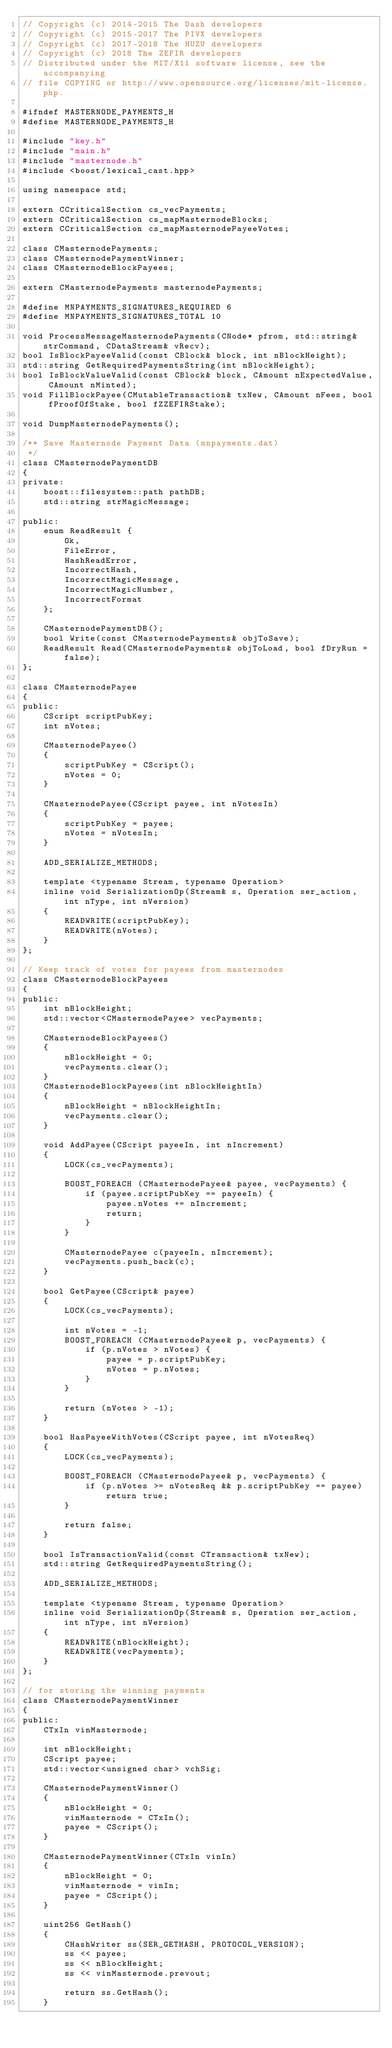<code> <loc_0><loc_0><loc_500><loc_500><_C_>// Copyright (c) 2014-2015 The Dash developers
// Copyright (c) 2015-2017 The PIVX developers
// Copyright (c) 2017-2018 The HUZU developers
// Copyright (c) 2018 The ZEFIR developers
// Distributed under the MIT/X11 software license, see the accompanying
// file COPYING or http://www.opensource.org/licenses/mit-license.php.

#ifndef MASTERNODE_PAYMENTS_H
#define MASTERNODE_PAYMENTS_H

#include "key.h"
#include "main.h"
#include "masternode.h"
#include <boost/lexical_cast.hpp>

using namespace std;

extern CCriticalSection cs_vecPayments;
extern CCriticalSection cs_mapMasternodeBlocks;
extern CCriticalSection cs_mapMasternodePayeeVotes;

class CMasternodePayments;
class CMasternodePaymentWinner;
class CMasternodeBlockPayees;

extern CMasternodePayments masternodePayments;

#define MNPAYMENTS_SIGNATURES_REQUIRED 6
#define MNPAYMENTS_SIGNATURES_TOTAL 10

void ProcessMessageMasternodePayments(CNode* pfrom, std::string& strCommand, CDataStream& vRecv);
bool IsBlockPayeeValid(const CBlock& block, int nBlockHeight);
std::string GetRequiredPaymentsString(int nBlockHeight);
bool IsBlockValueValid(const CBlock& block, CAmount nExpectedValue, CAmount nMinted);
void FillBlockPayee(CMutableTransaction& txNew, CAmount nFees, bool fProofOfStake, bool fZZEFIRStake);

void DumpMasternodePayments();

/** Save Masternode Payment Data (mnpayments.dat)
 */
class CMasternodePaymentDB
{
private:
    boost::filesystem::path pathDB;
    std::string strMagicMessage;

public:
    enum ReadResult {
        Ok,
        FileError,
        HashReadError,
        IncorrectHash,
        IncorrectMagicMessage,
        IncorrectMagicNumber,
        IncorrectFormat
    };

    CMasternodePaymentDB();
    bool Write(const CMasternodePayments& objToSave);
    ReadResult Read(CMasternodePayments& objToLoad, bool fDryRun = false);
};

class CMasternodePayee
{
public:
    CScript scriptPubKey;
    int nVotes;

    CMasternodePayee()
    {
        scriptPubKey = CScript();
        nVotes = 0;
    }

    CMasternodePayee(CScript payee, int nVotesIn)
    {
        scriptPubKey = payee;
        nVotes = nVotesIn;
    }

    ADD_SERIALIZE_METHODS;

    template <typename Stream, typename Operation>
    inline void SerializationOp(Stream& s, Operation ser_action, int nType, int nVersion)
    {
        READWRITE(scriptPubKey);
        READWRITE(nVotes);
    }
};

// Keep track of votes for payees from masternodes
class CMasternodeBlockPayees
{
public:
    int nBlockHeight;
    std::vector<CMasternodePayee> vecPayments;

    CMasternodeBlockPayees()
    {
        nBlockHeight = 0;
        vecPayments.clear();
    }
    CMasternodeBlockPayees(int nBlockHeightIn)
    {
        nBlockHeight = nBlockHeightIn;
        vecPayments.clear();
    }

    void AddPayee(CScript payeeIn, int nIncrement)
    {
        LOCK(cs_vecPayments);

        BOOST_FOREACH (CMasternodePayee& payee, vecPayments) {
            if (payee.scriptPubKey == payeeIn) {
                payee.nVotes += nIncrement;
                return;
            }
        }

        CMasternodePayee c(payeeIn, nIncrement);
        vecPayments.push_back(c);
    }

    bool GetPayee(CScript& payee)
    {
        LOCK(cs_vecPayments);

        int nVotes = -1;
        BOOST_FOREACH (CMasternodePayee& p, vecPayments) {
            if (p.nVotes > nVotes) {
                payee = p.scriptPubKey;
                nVotes = p.nVotes;
            }
        }

        return (nVotes > -1);
    }

    bool HasPayeeWithVotes(CScript payee, int nVotesReq)
    {
        LOCK(cs_vecPayments);

        BOOST_FOREACH (CMasternodePayee& p, vecPayments) {
            if (p.nVotes >= nVotesReq && p.scriptPubKey == payee) return true;
        }

        return false;
    }

    bool IsTransactionValid(const CTransaction& txNew);
    std::string GetRequiredPaymentsString();

    ADD_SERIALIZE_METHODS;

    template <typename Stream, typename Operation>
    inline void SerializationOp(Stream& s, Operation ser_action, int nType, int nVersion)
    {
        READWRITE(nBlockHeight);
        READWRITE(vecPayments);
    }
};

// for storing the winning payments
class CMasternodePaymentWinner
{
public:
    CTxIn vinMasternode;

    int nBlockHeight;
    CScript payee;
    std::vector<unsigned char> vchSig;

    CMasternodePaymentWinner()
    {
        nBlockHeight = 0;
        vinMasternode = CTxIn();
        payee = CScript();
    }

    CMasternodePaymentWinner(CTxIn vinIn)
    {
        nBlockHeight = 0;
        vinMasternode = vinIn;
        payee = CScript();
    }

    uint256 GetHash()
    {
        CHashWriter ss(SER_GETHASH, PROTOCOL_VERSION);
        ss << payee;
        ss << nBlockHeight;
        ss << vinMasternode.prevout;

        return ss.GetHash();
    }
</code> 